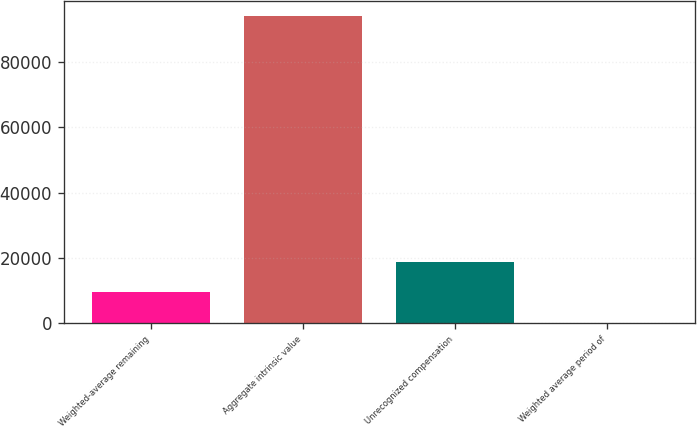Convert chart to OTSL. <chart><loc_0><loc_0><loc_500><loc_500><bar_chart><fcel>Weighted-average remaining<fcel>Aggregate intrinsic value<fcel>Unrecognized compensation<fcel>Weighted average period of<nl><fcel>9409.8<fcel>94086<fcel>18818.3<fcel>1.33<nl></chart> 